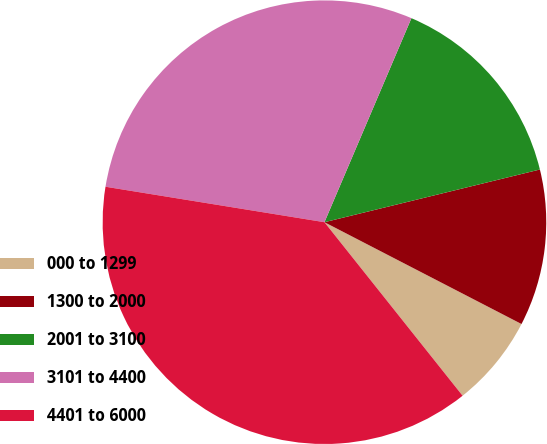Convert chart to OTSL. <chart><loc_0><loc_0><loc_500><loc_500><pie_chart><fcel>000 to 1299<fcel>1300 to 2000<fcel>2001 to 3100<fcel>3101 to 4400<fcel>4401 to 6000<nl><fcel>6.71%<fcel>11.41%<fcel>14.77%<fcel>28.86%<fcel>38.26%<nl></chart> 